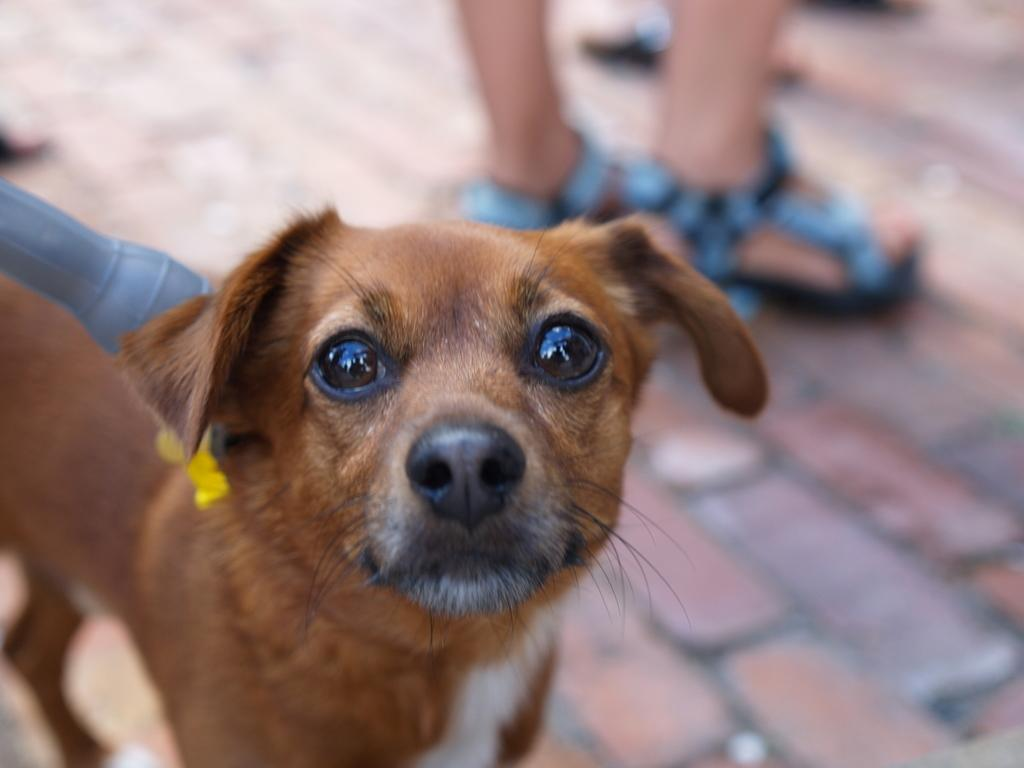What type of animal can be seen in the image? There is a dog in the image. What else is present in the image besides the dog? There is an object and a person in the image. Can you describe the time of day when the image was taken? The image appears to be taken during the day. What book is the person reading in the image? There is no book or reading activity present in the image. 